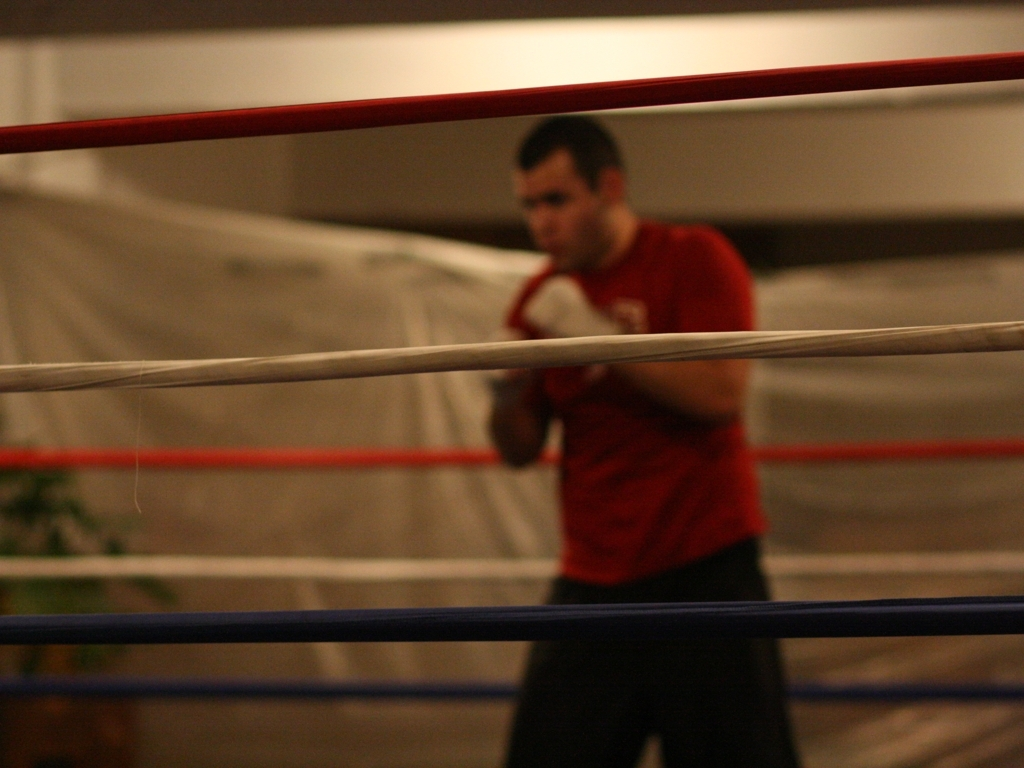What is the activity taking place? The individual in the image seems to be practicing boxing. He is inside a boxing ring and wearing boxing gloves, suggesting a training session or preparation for sparring. 